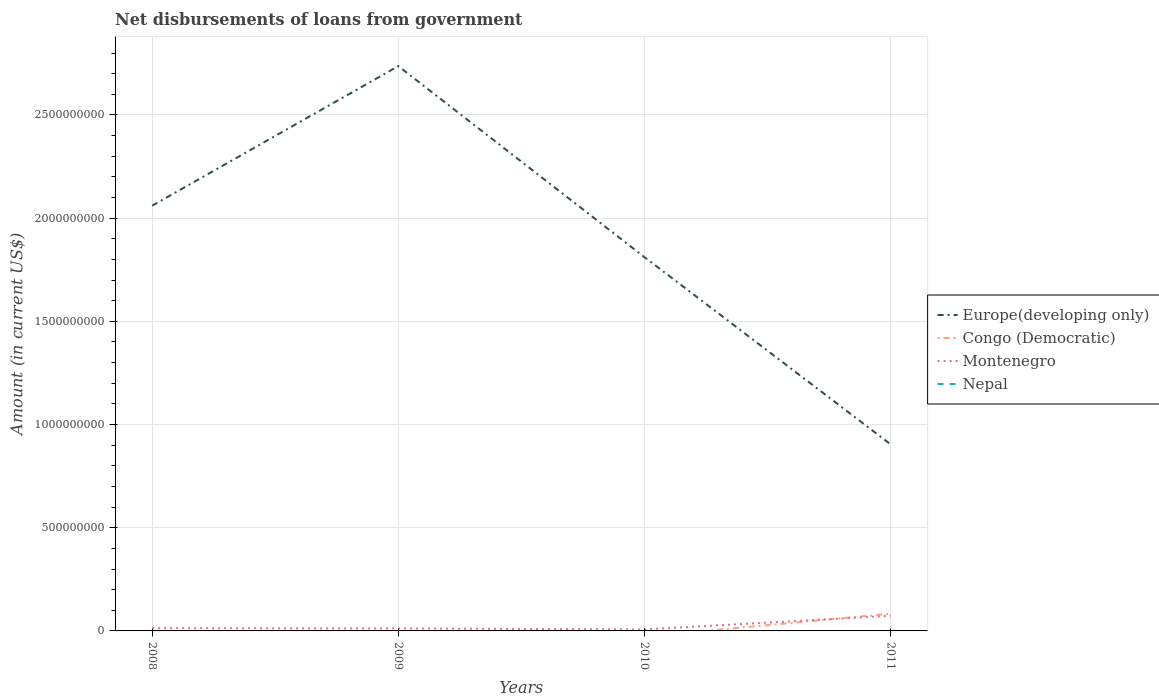How many different coloured lines are there?
Your answer should be compact. 3. Across all years, what is the maximum amount of loan disbursed from government in Congo (Democratic)?
Give a very brief answer. 0. What is the total amount of loan disbursed from government in Montenegro in the graph?
Make the answer very short. 1.39e+06. What is the difference between the highest and the second highest amount of loan disbursed from government in Montenegro?
Keep it short and to the point. 6.66e+07. Is the amount of loan disbursed from government in Europe(developing only) strictly greater than the amount of loan disbursed from government in Congo (Democratic) over the years?
Your answer should be compact. No. How many years are there in the graph?
Provide a short and direct response. 4. What is the difference between two consecutive major ticks on the Y-axis?
Your answer should be compact. 5.00e+08. How many legend labels are there?
Make the answer very short. 4. What is the title of the graph?
Your response must be concise. Net disbursements of loans from government. What is the Amount (in current US$) of Europe(developing only) in 2008?
Make the answer very short. 2.06e+09. What is the Amount (in current US$) in Montenegro in 2008?
Make the answer very short. 1.35e+07. What is the Amount (in current US$) of Nepal in 2008?
Offer a very short reply. 0. What is the Amount (in current US$) in Europe(developing only) in 2009?
Keep it short and to the point. 2.74e+09. What is the Amount (in current US$) of Congo (Democratic) in 2009?
Your answer should be compact. 0. What is the Amount (in current US$) of Montenegro in 2009?
Make the answer very short. 1.21e+07. What is the Amount (in current US$) in Europe(developing only) in 2010?
Your response must be concise. 1.81e+09. What is the Amount (in current US$) in Montenegro in 2010?
Make the answer very short. 7.04e+06. What is the Amount (in current US$) in Nepal in 2010?
Give a very brief answer. 0. What is the Amount (in current US$) of Europe(developing only) in 2011?
Give a very brief answer. 9.04e+08. What is the Amount (in current US$) in Congo (Democratic) in 2011?
Your answer should be very brief. 8.36e+07. What is the Amount (in current US$) of Montenegro in 2011?
Keep it short and to the point. 7.36e+07. Across all years, what is the maximum Amount (in current US$) in Europe(developing only)?
Your answer should be compact. 2.74e+09. Across all years, what is the maximum Amount (in current US$) in Congo (Democratic)?
Your answer should be very brief. 8.36e+07. Across all years, what is the maximum Amount (in current US$) in Montenegro?
Your answer should be compact. 7.36e+07. Across all years, what is the minimum Amount (in current US$) in Europe(developing only)?
Make the answer very short. 9.04e+08. Across all years, what is the minimum Amount (in current US$) in Congo (Democratic)?
Your answer should be compact. 0. Across all years, what is the minimum Amount (in current US$) of Montenegro?
Ensure brevity in your answer.  7.04e+06. What is the total Amount (in current US$) of Europe(developing only) in the graph?
Make the answer very short. 7.51e+09. What is the total Amount (in current US$) in Congo (Democratic) in the graph?
Offer a very short reply. 8.36e+07. What is the total Amount (in current US$) in Montenegro in the graph?
Provide a short and direct response. 1.06e+08. What is the total Amount (in current US$) in Nepal in the graph?
Make the answer very short. 0. What is the difference between the Amount (in current US$) in Europe(developing only) in 2008 and that in 2009?
Your answer should be compact. -6.76e+08. What is the difference between the Amount (in current US$) of Montenegro in 2008 and that in 2009?
Offer a terse response. 1.39e+06. What is the difference between the Amount (in current US$) in Europe(developing only) in 2008 and that in 2010?
Keep it short and to the point. 2.49e+08. What is the difference between the Amount (in current US$) in Montenegro in 2008 and that in 2010?
Provide a short and direct response. 6.42e+06. What is the difference between the Amount (in current US$) of Europe(developing only) in 2008 and that in 2011?
Provide a succinct answer. 1.16e+09. What is the difference between the Amount (in current US$) in Montenegro in 2008 and that in 2011?
Make the answer very short. -6.02e+07. What is the difference between the Amount (in current US$) in Europe(developing only) in 2009 and that in 2010?
Offer a very short reply. 9.26e+08. What is the difference between the Amount (in current US$) of Montenegro in 2009 and that in 2010?
Your answer should be very brief. 5.03e+06. What is the difference between the Amount (in current US$) in Europe(developing only) in 2009 and that in 2011?
Make the answer very short. 1.83e+09. What is the difference between the Amount (in current US$) in Montenegro in 2009 and that in 2011?
Offer a very short reply. -6.16e+07. What is the difference between the Amount (in current US$) in Europe(developing only) in 2010 and that in 2011?
Your answer should be compact. 9.07e+08. What is the difference between the Amount (in current US$) in Montenegro in 2010 and that in 2011?
Give a very brief answer. -6.66e+07. What is the difference between the Amount (in current US$) of Europe(developing only) in 2008 and the Amount (in current US$) of Montenegro in 2009?
Ensure brevity in your answer.  2.05e+09. What is the difference between the Amount (in current US$) in Europe(developing only) in 2008 and the Amount (in current US$) in Montenegro in 2010?
Keep it short and to the point. 2.05e+09. What is the difference between the Amount (in current US$) of Europe(developing only) in 2008 and the Amount (in current US$) of Congo (Democratic) in 2011?
Your response must be concise. 1.98e+09. What is the difference between the Amount (in current US$) in Europe(developing only) in 2008 and the Amount (in current US$) in Montenegro in 2011?
Your answer should be compact. 1.99e+09. What is the difference between the Amount (in current US$) in Europe(developing only) in 2009 and the Amount (in current US$) in Montenegro in 2010?
Your answer should be very brief. 2.73e+09. What is the difference between the Amount (in current US$) in Europe(developing only) in 2009 and the Amount (in current US$) in Congo (Democratic) in 2011?
Keep it short and to the point. 2.65e+09. What is the difference between the Amount (in current US$) of Europe(developing only) in 2009 and the Amount (in current US$) of Montenegro in 2011?
Ensure brevity in your answer.  2.66e+09. What is the difference between the Amount (in current US$) of Europe(developing only) in 2010 and the Amount (in current US$) of Congo (Democratic) in 2011?
Offer a terse response. 1.73e+09. What is the difference between the Amount (in current US$) of Europe(developing only) in 2010 and the Amount (in current US$) of Montenegro in 2011?
Your response must be concise. 1.74e+09. What is the average Amount (in current US$) of Europe(developing only) per year?
Give a very brief answer. 1.88e+09. What is the average Amount (in current US$) in Congo (Democratic) per year?
Keep it short and to the point. 2.09e+07. What is the average Amount (in current US$) in Montenegro per year?
Keep it short and to the point. 2.66e+07. What is the average Amount (in current US$) in Nepal per year?
Provide a short and direct response. 0. In the year 2008, what is the difference between the Amount (in current US$) in Europe(developing only) and Amount (in current US$) in Montenegro?
Make the answer very short. 2.05e+09. In the year 2009, what is the difference between the Amount (in current US$) in Europe(developing only) and Amount (in current US$) in Montenegro?
Ensure brevity in your answer.  2.72e+09. In the year 2010, what is the difference between the Amount (in current US$) of Europe(developing only) and Amount (in current US$) of Montenegro?
Your answer should be very brief. 1.80e+09. In the year 2011, what is the difference between the Amount (in current US$) in Europe(developing only) and Amount (in current US$) in Congo (Democratic)?
Offer a very short reply. 8.20e+08. In the year 2011, what is the difference between the Amount (in current US$) in Europe(developing only) and Amount (in current US$) in Montenegro?
Provide a short and direct response. 8.30e+08. In the year 2011, what is the difference between the Amount (in current US$) of Congo (Democratic) and Amount (in current US$) of Montenegro?
Make the answer very short. 9.93e+06. What is the ratio of the Amount (in current US$) of Europe(developing only) in 2008 to that in 2009?
Your answer should be very brief. 0.75. What is the ratio of the Amount (in current US$) of Montenegro in 2008 to that in 2009?
Provide a succinct answer. 1.11. What is the ratio of the Amount (in current US$) of Europe(developing only) in 2008 to that in 2010?
Your answer should be very brief. 1.14. What is the ratio of the Amount (in current US$) in Montenegro in 2008 to that in 2010?
Offer a very short reply. 1.91. What is the ratio of the Amount (in current US$) in Europe(developing only) in 2008 to that in 2011?
Ensure brevity in your answer.  2.28. What is the ratio of the Amount (in current US$) of Montenegro in 2008 to that in 2011?
Your response must be concise. 0.18. What is the ratio of the Amount (in current US$) in Europe(developing only) in 2009 to that in 2010?
Provide a short and direct response. 1.51. What is the ratio of the Amount (in current US$) of Montenegro in 2009 to that in 2010?
Give a very brief answer. 1.72. What is the ratio of the Amount (in current US$) of Europe(developing only) in 2009 to that in 2011?
Offer a very short reply. 3.03. What is the ratio of the Amount (in current US$) of Montenegro in 2009 to that in 2011?
Provide a succinct answer. 0.16. What is the ratio of the Amount (in current US$) of Europe(developing only) in 2010 to that in 2011?
Keep it short and to the point. 2. What is the ratio of the Amount (in current US$) of Montenegro in 2010 to that in 2011?
Your answer should be compact. 0.1. What is the difference between the highest and the second highest Amount (in current US$) of Europe(developing only)?
Offer a very short reply. 6.76e+08. What is the difference between the highest and the second highest Amount (in current US$) in Montenegro?
Your answer should be compact. 6.02e+07. What is the difference between the highest and the lowest Amount (in current US$) in Europe(developing only)?
Provide a succinct answer. 1.83e+09. What is the difference between the highest and the lowest Amount (in current US$) in Congo (Democratic)?
Ensure brevity in your answer.  8.36e+07. What is the difference between the highest and the lowest Amount (in current US$) of Montenegro?
Give a very brief answer. 6.66e+07. 